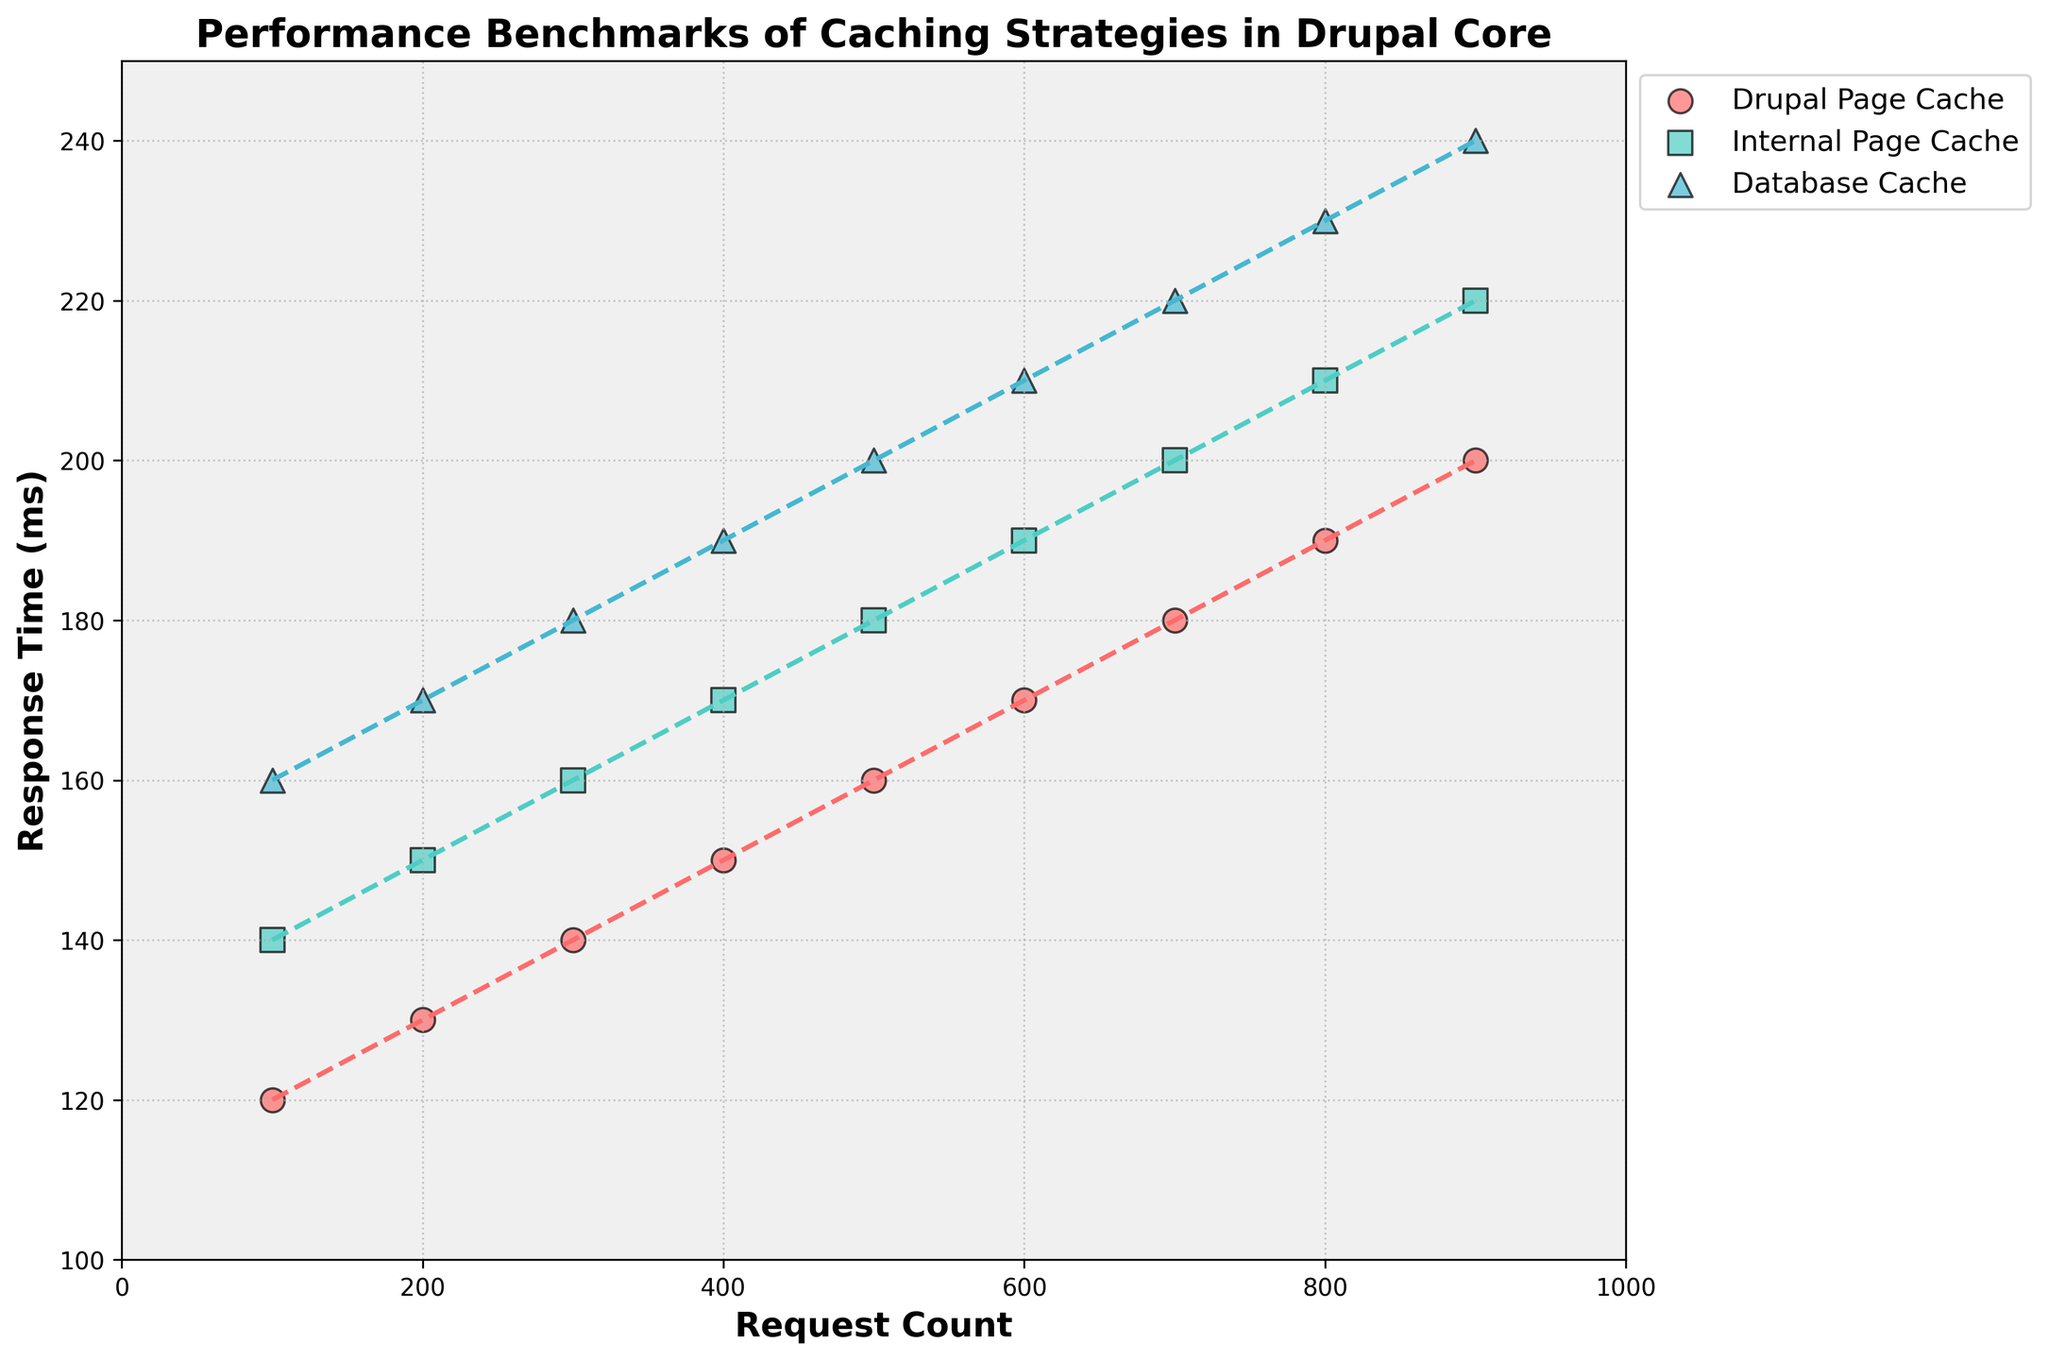What is the title of the plot? The title is prominently printed at the top of the plot. It reads "Performance Benchmarks of Caching Strategies in Drupal Core".
Answer: Performance Benchmarks of Caching Strategies in Drupal Core Which cache strategy shows the lowest response time for 400 requests? To determine the response time for 400 requests, find the point on the x-axis. The lowest response time for 400 requests is represented by the lowest point among the three strategies. The Drupal Page Cache is at 150 ms, which is the lowest.
Answer: Drupal Page Cache Which cache strategy has the highest response time for 900 requests? For 900 requests, identify the response time for all strategies. Database Cache is at 240 ms, which is the highest among the three strategies.
Answer: Database Cache What is the primary color used for the Internal Page Cache data points? Data points for each cache strategy are colored differently. Internal Page Cache data points are colored in a bright, teal-greenish color.
Answer: Teal-green Can you calculate the difference in response time between the Internal Page Cache and Database Cache strategies for 600 requests? For 600 requests, the response times for Internal Page Cache and Database Cache are 190 ms and 210 ms respectively. The difference is 210 ms - 190 ms.
Answer: 20 ms What trend can be observed for the Drupal Page Cache strategy as the request count increases? By observing the trend line for the Drupal Page Cache, we notice it has a polynomial curve that gradually increases as the request count goes up, indicating response time increases slightly with the increased request count.
Answer: Response time gradually increases How do the response times for Internal Page Cache and Database Cache compare at 800 requests? At 800 requests, compare the response times for the Internal Page Cache (210 ms) and Database Cache (230 ms).
Answer: Internal Page Cache is 20 ms less What is the overall pattern of the trend lines for all three caching strategies? All trend lines are plotted with dotted lines. They show polynomial fits, and all trends indicate that response times incrementally increase as the request count rises.
Answer: Polynomial increase Is there any strategy whose response time remains constant regardless of request count? By looking at all the trend lines, no strategy shows a flat line; therefore, all trends depict increasing response times with rising request count, meaning no constant response time is observed.
Answer: No Which caching strategy generally performs the best in terms of response time? By comparing the overall positioning of the response times and trend lines, the Drupal Page Cache consistently shows the lowest response times across all request counts.
Answer: Drupal Page Cache 